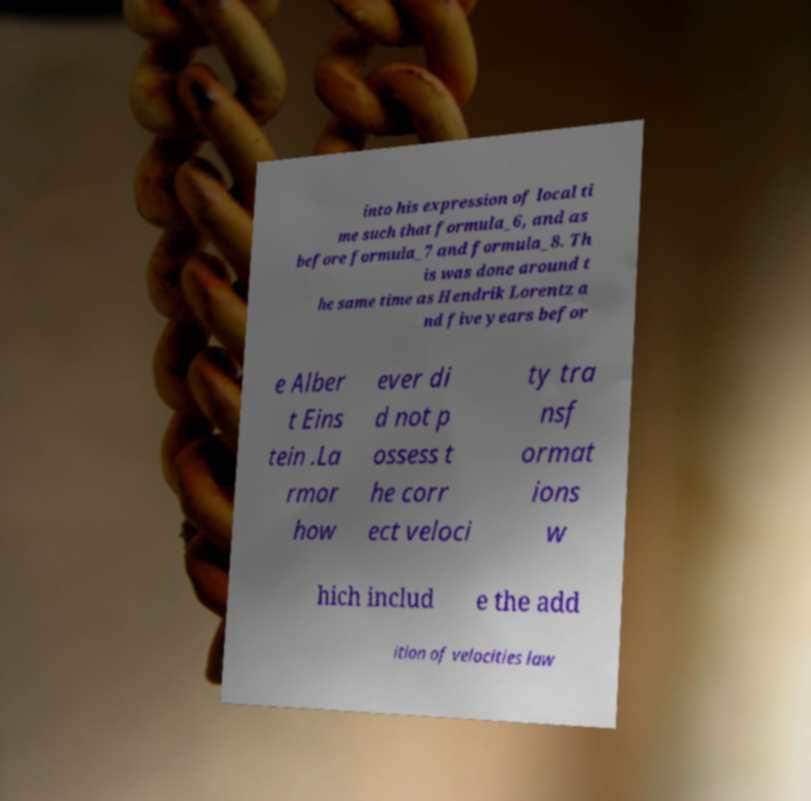For documentation purposes, I need the text within this image transcribed. Could you provide that? into his expression of local ti me such that formula_6, and as before formula_7 and formula_8. Th is was done around t he same time as Hendrik Lorentz a nd five years befor e Alber t Eins tein .La rmor how ever di d not p ossess t he corr ect veloci ty tra nsf ormat ions w hich includ e the add ition of velocities law 